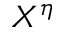<formula> <loc_0><loc_0><loc_500><loc_500>X ^ { \eta }</formula> 